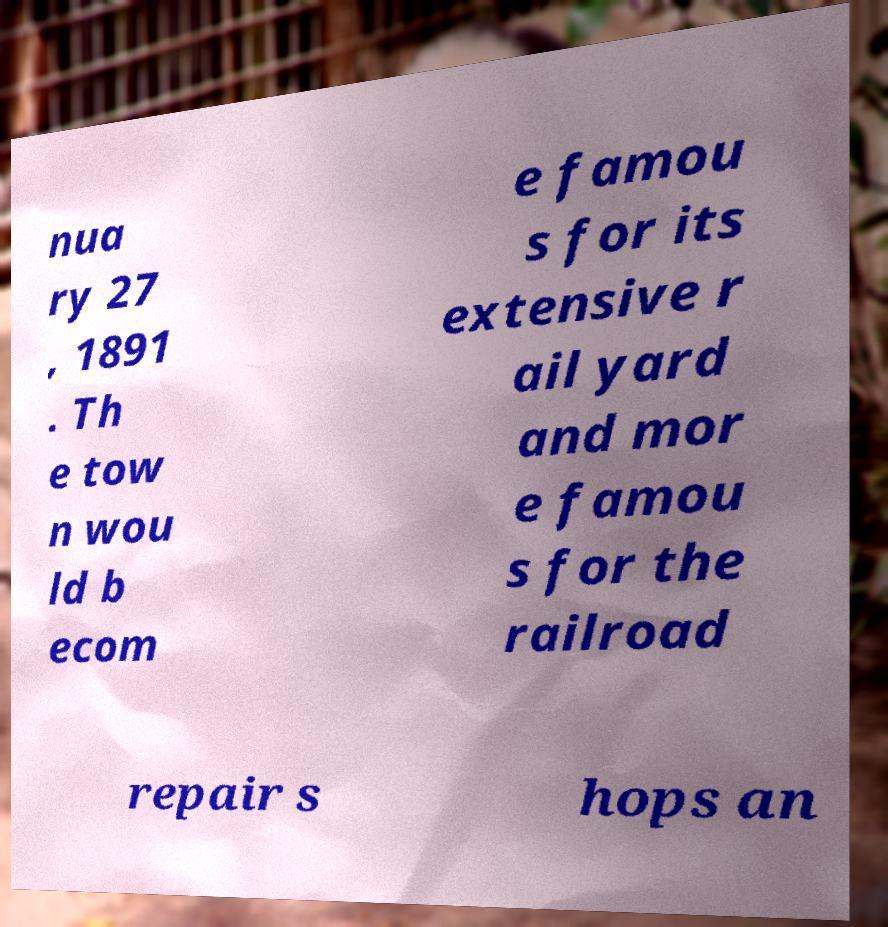What messages or text are displayed in this image? I need them in a readable, typed format. nua ry 27 , 1891 . Th e tow n wou ld b ecom e famou s for its extensive r ail yard and mor e famou s for the railroad repair s hops an 